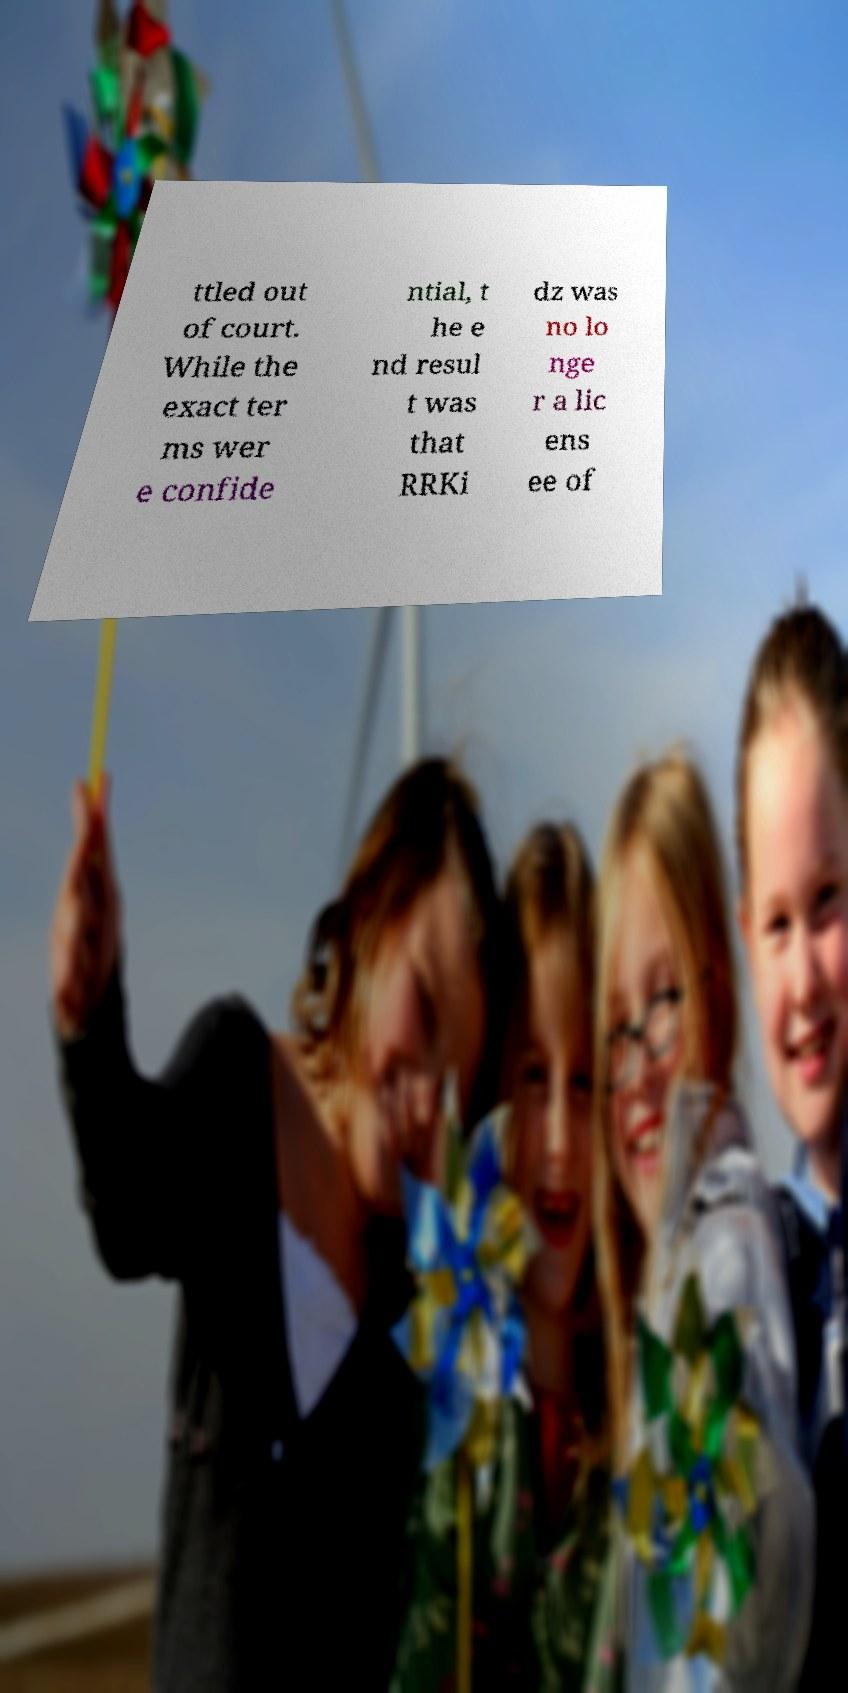What messages or text are displayed in this image? I need them in a readable, typed format. ttled out of court. While the exact ter ms wer e confide ntial, t he e nd resul t was that RRKi dz was no lo nge r a lic ens ee of 